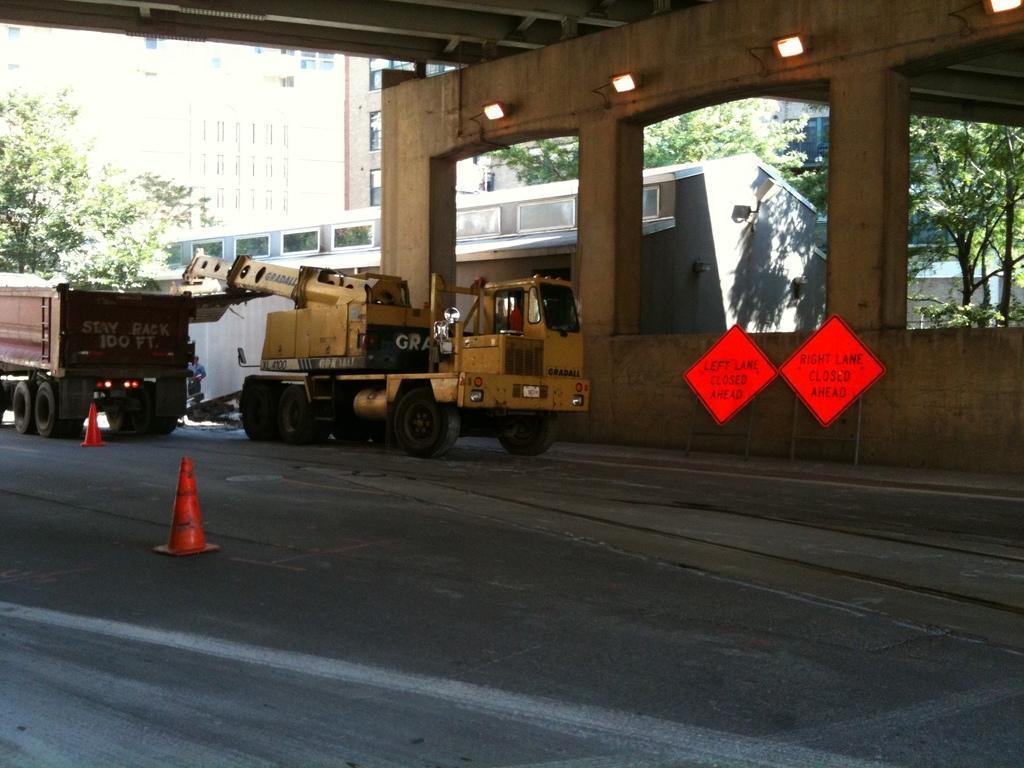Describe this image in one or two sentences. In this image we can see a person, there are two vehicles, there are two traffic cones, buildings, lights, also we can see trees. 